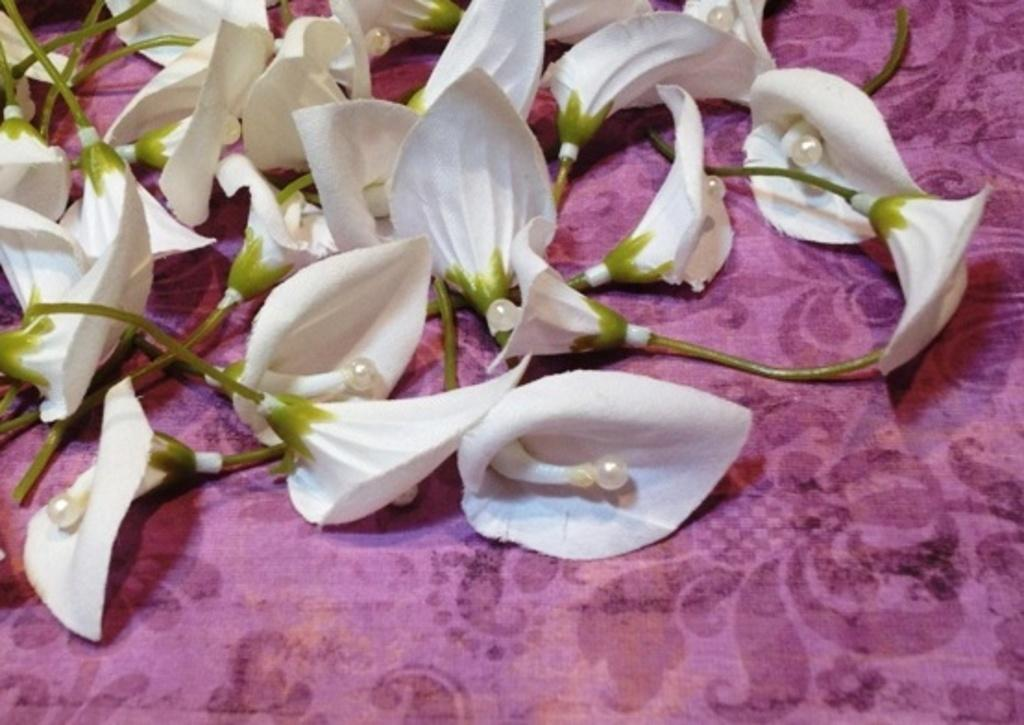What type of flowers are present in the image? There are plastic flowers in the image. What is the color of the cloth on which the flowers are placed? The plastic flowers are on a purple cloth. What is the argument about in the image? There is no argument present in the image; it features plastic flowers on a purple cloth. What type of pet can be seen interacting with the plastic flowers in the image? There is no pet present in the image; it only features plastic flowers on a purple cloth. 